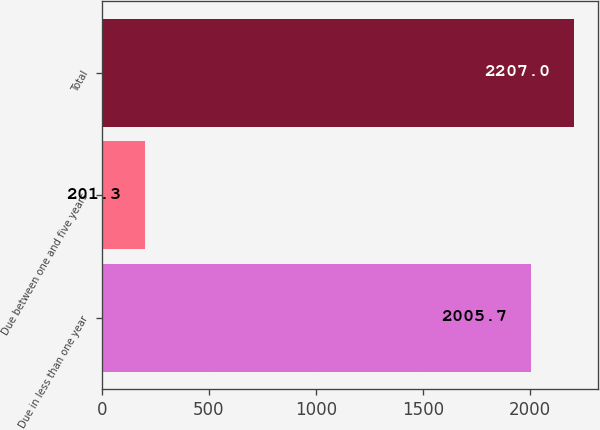Convert chart to OTSL. <chart><loc_0><loc_0><loc_500><loc_500><bar_chart><fcel>Due in less than one year<fcel>Due between one and five years<fcel>Total<nl><fcel>2005.7<fcel>201.3<fcel>2207<nl></chart> 